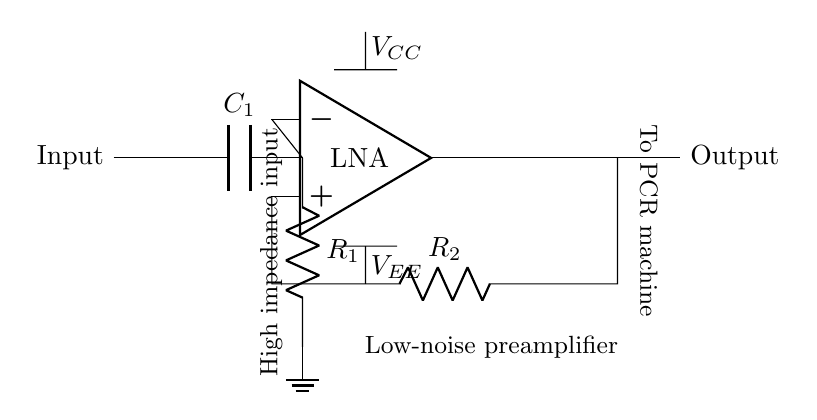What is the type of operational amplifier used in this circuit? The circuit diagram labels the operational amplifier as "LNA," which stands for Low Noise Amplifier. The designation in the diagram indicates its primary purpose within the circuit.
Answer: Low Noise Amplifier What components are used in the feedback network? The feedback network consists of one resistor labeled as "R_2". Since feedback is critical for amplifier stability and performance, identifying the component helps in understanding the circuit design.
Answer: R_2 What is connected to the high impedance input of the operational amplifier? The high impedance input node is directly connected to "C_1" (a capacitor), which indicates the circuit may be processing weak signals by integrating the incoming current.
Answer: C_1 What is the function of resistor R_1 in this circuit? Resistor "R_1" is connected to ground, indicating it serves as a biasing element for the input, helping to set the initial operating point for the amplifier.
Answer: Biasing What voltages are supplied to the operational amplifier in this circuit? The operational amplifier is supplied with “V_CC” and “V_EE” voltage labels that indicate power supply levels for its operation, essential for determining amplifier functionality.
Answer: V_CC and V_EE Explain the connection of the output in this circuit. The output of the operational amplifier is directly connected to the next component labeled as "Output", and it serves as the signal pathway leading to the PCR machine, indicating processed signal transfer.
Answer: Output 